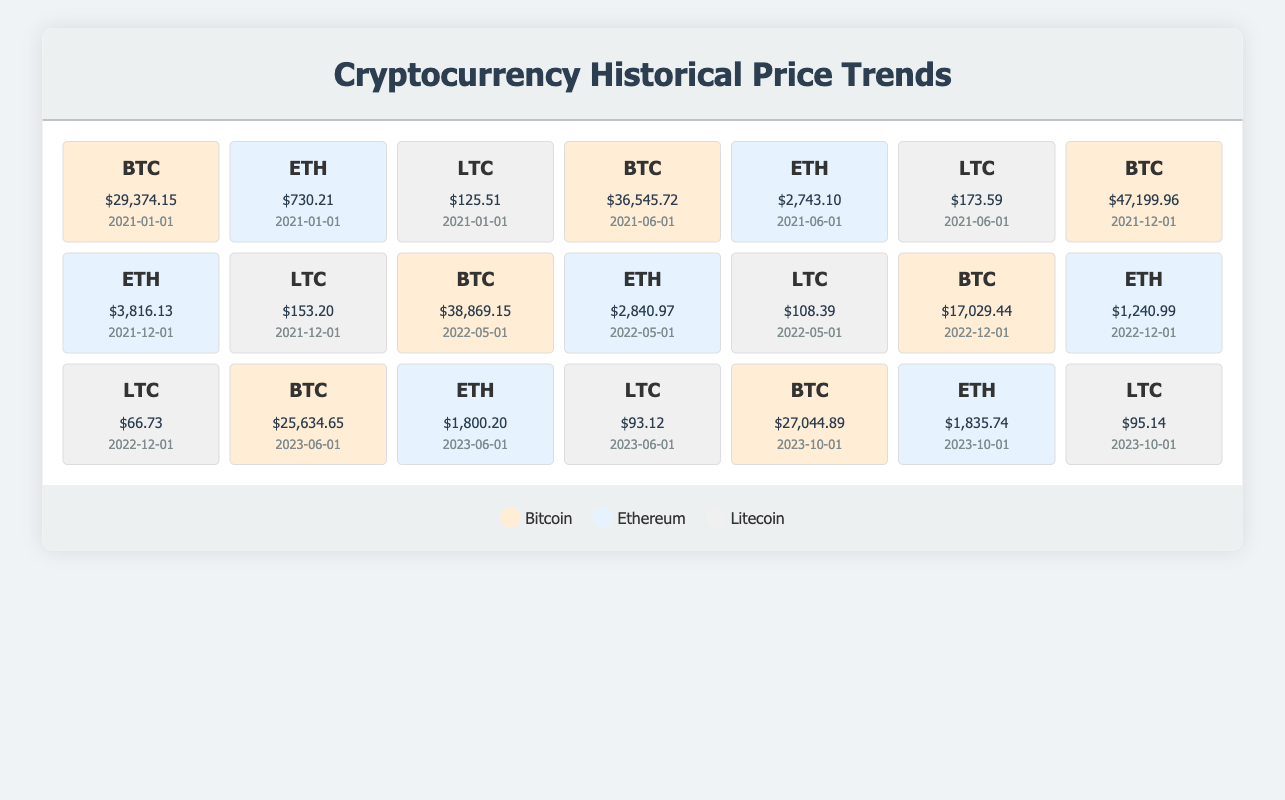What was the price of Ethereum on June 1, 2021? Looking at the table, I locate the entry for Ethereum on June 1, 2021, where the price is listed as 2743.10 USD.
Answer: 2743.10 USD What is the highest historical price for Litecoin in this data? The table shows multiple price points for Litecoin. The highest price can be found by scanning through all the listed values. The maximum price is 173.59 USD from June 1, 2021.
Answer: 173.59 USD What was the price decline of Bitcoin from December 1, 2021, to December 1, 2022? To find the price decline, I compare the price on December 1, 2021 (47199.96 USD) to December 1, 2022 (17029.44 USD). The decline is calculated as 47199.96 - 17029.44 = 30170.52 USD.
Answer: 30170.52 USD Is the price of Ethereum on June 1, 2023, less than its price on December 1, 2022? I check the price of Ethereum on June 1, 2023 (1800.20 USD) and compare it to the price on December 1, 2022 (1240.99 USD). Since 1800.20 is greater than 1240.99, the statement is false.
Answer: False What is the average price of Litecoin from 2021-2023? First, I list the prices for Litecoin: 125.51, 173.59, 153.20, 108.39, 66.73, 93.12, and 95.14 USD. I sum these prices which gives 813.68 USD, and there are 7 prices, so the average is 813.68 / 7 = 116.24 USD.
Answer: 116.24 USD What was the percentage increase in Bitcoin's price from June 1, 2023, to October 1, 2023? The prices to compare are 25634.65 USD on June 1, 2023, and 27044.89 USD on October 1, 2023. The increase is calculated as (27044.89 - 25634.65) / 25634.65 * 100 = 4.84%.
Answer: 4.84% What was the lowest price recorded for Ethereum during this period? I find the lowest price in the table by reviewing the prices listed for Ethereum: 730.21, 2743.10, 3816.13, 2840.97, 1240.99, 1800.20, and 1835.74 USD. The minimum value is 730.21 USD from January 1, 2021.
Answer: 730.21 USD Was Litecoin ever priced above 150 USD in this data? I review the Litecoin prices, which are 125.51, 173.59, 153.20, 108.39, 66.73, 93.12, and 95.14 USD. Since 173.59 and 153.20 are both above 150, the answer to this question is yes.
Answer: Yes What was the price trend of Bitcoin from January 2021 to October 2023? Observing the price points, Bitcoin started at 29374.15 USD, peaked in December 2021 at 47199.96, declined significantly to 17029.44 USD in December 2022, then gradually rose to 25634.65 USD by June 2023, and continued up to 27044.89 USD in October 2023. Overall, the trend shows a high volatility with significant ups and downs.
Answer: Fluctuating with a significant peak and decline 